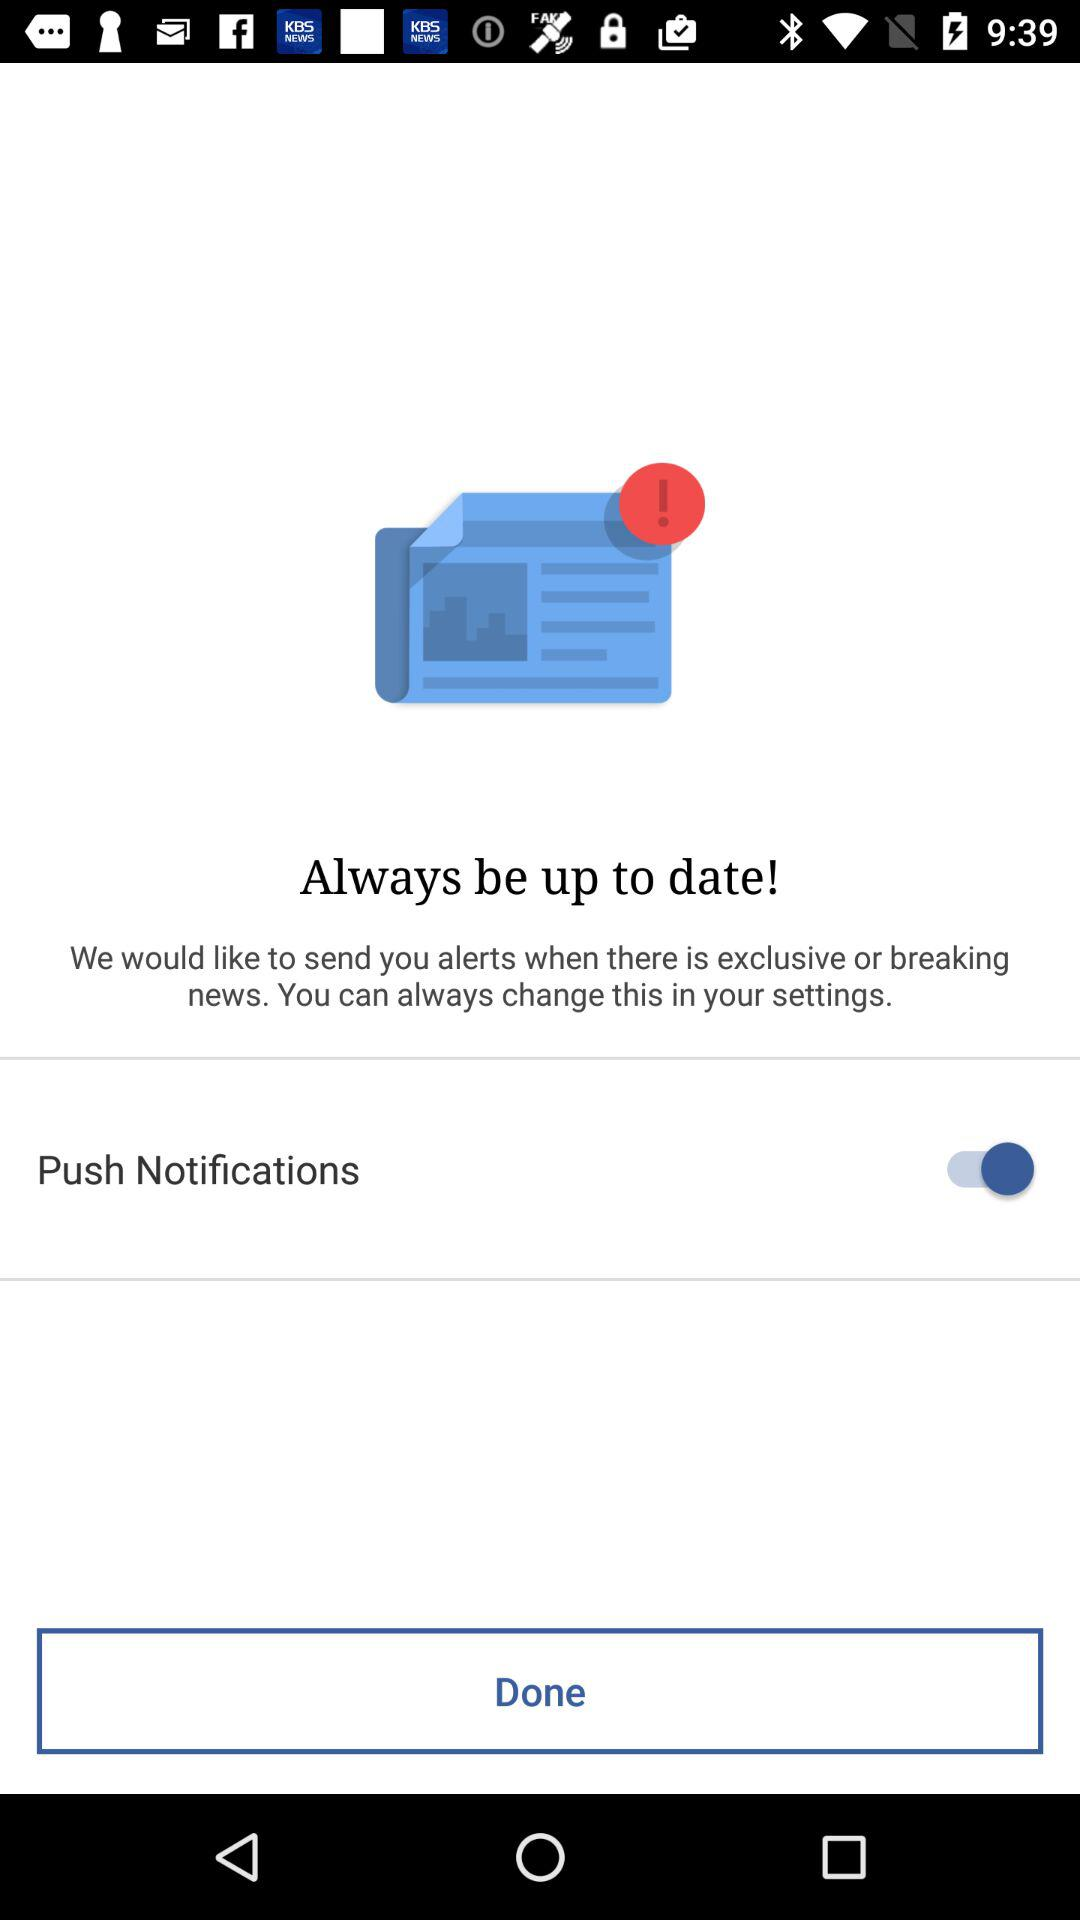What is the status of Push Notification? The status is on. 